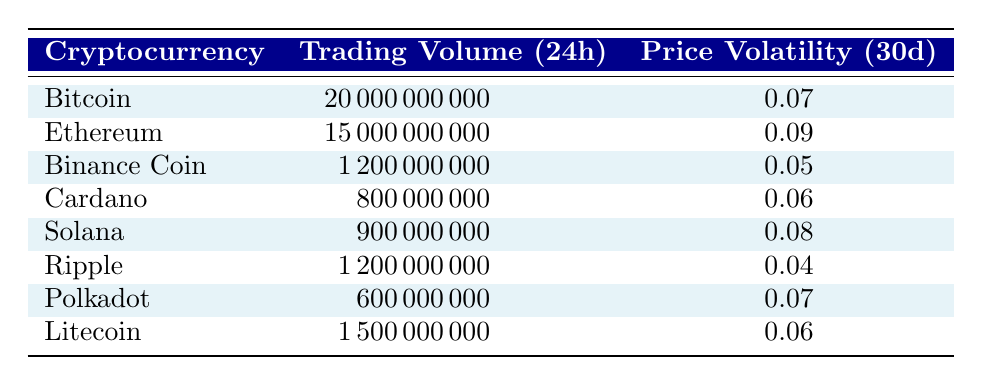What is the trading volume of Bitcoin? The table shows that Bitcoin has a trading volume of 20000000000.
Answer: 20000000000 Which cryptocurrency has the highest price volatility? By examining the table, Ethereum has the highest price volatility at 0.09.
Answer: Ethereum Calculate the average trading volume of the listed cryptocurrencies. The trading volumes are 20000000000, 15000000000, 1200000000, 800000000, 900000000, 1200000000, 600000000, and 1500000000. The sum is 233,000,000,00 and there are 8 cryptocurrencies, so the average is 23300000000/8 = 2912500000.
Answer: 2912500000 Is the price volatility of Ripple greater than that of Cardano? The price volatility of Ripple is 0.04 and Cardano is 0.06; therefore, Ripple's volatility is not greater.
Answer: No What is the difference in trading volume between the highest and lowest trading cryptocurrencies? The highest trading volume is held by Bitcoin at 20000000000, and the lowest trading volume is by Polkadot at 600000000. The difference is 20000000000 - 600000000 = 19400000000.
Answer: 19400000000 How many cryptocurrencies have a price volatility less than 0.07? Looking at the table, Binance Coin (0.05), Ripple (0.04), and Litecoin (0.06) have a price volatility less than 0.07, totaling 3 cryptocurrencies.
Answer: 3 Which cryptocurrency has the same price volatility as Polkadot? Polkadot has a price volatility of 0.07, and Bitcoin also has a volatility of 0.07, making them a match.
Answer: Bitcoin Is there a cryptocurrency with a trading volume of exactly 1200000000? Yes, both Ripple and Binance Coin have a trading volume of 1200000000.
Answer: Yes 